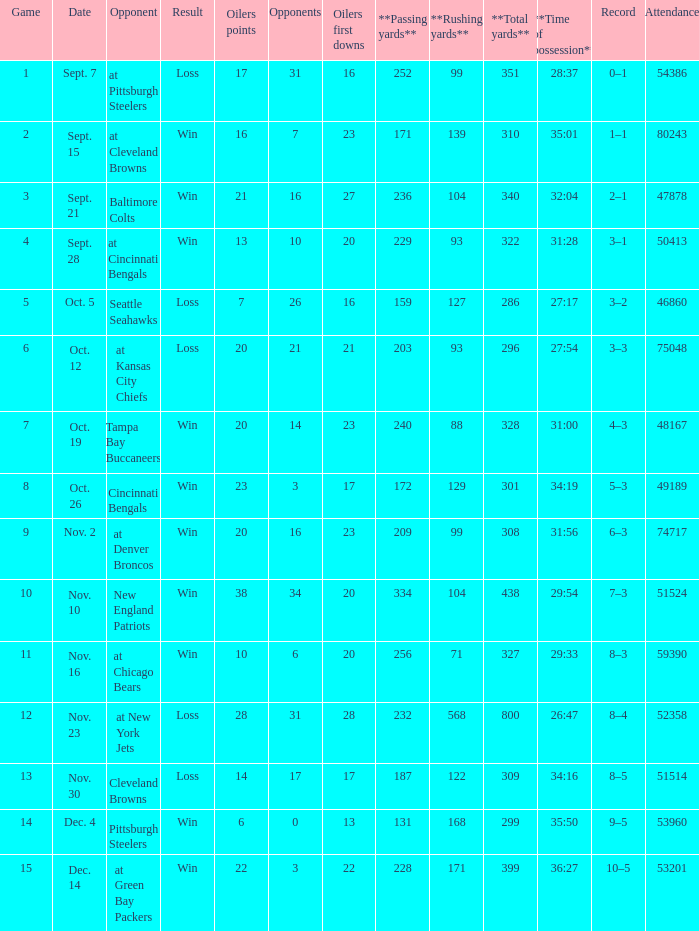What was the total opponents points for the game were the Oilers scored 21? 16.0. 